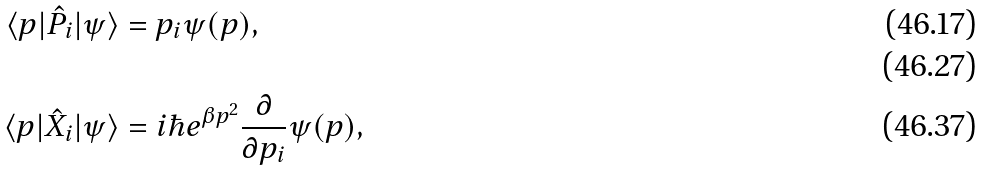Convert formula to latex. <formula><loc_0><loc_0><loc_500><loc_500>\langle p | \hat { P } _ { i } | \psi \rangle & = p _ { i } \psi ( p ) , \\ \\ \langle p | \hat { X } _ { i } | \psi \rangle & = i \hbar { e } ^ { \beta p ^ { 2 } } \frac { \partial } { \partial p _ { i } } \psi ( p ) ,</formula> 